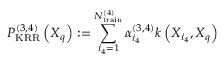<formula> <loc_0><loc_0><loc_500><loc_500>P _ { K R R } ^ { ( 3 , 4 ) } \left ( X _ { q } \right ) \colon = \sum _ { i _ { 4 } = 1 } ^ { N _ { t r a i n } ^ { ( 4 ) } } \alpha _ { i _ { 4 } } ^ { ( 3 , 4 ) } k \left ( X _ { i _ { 4 } } , X _ { q } \right )</formula> 